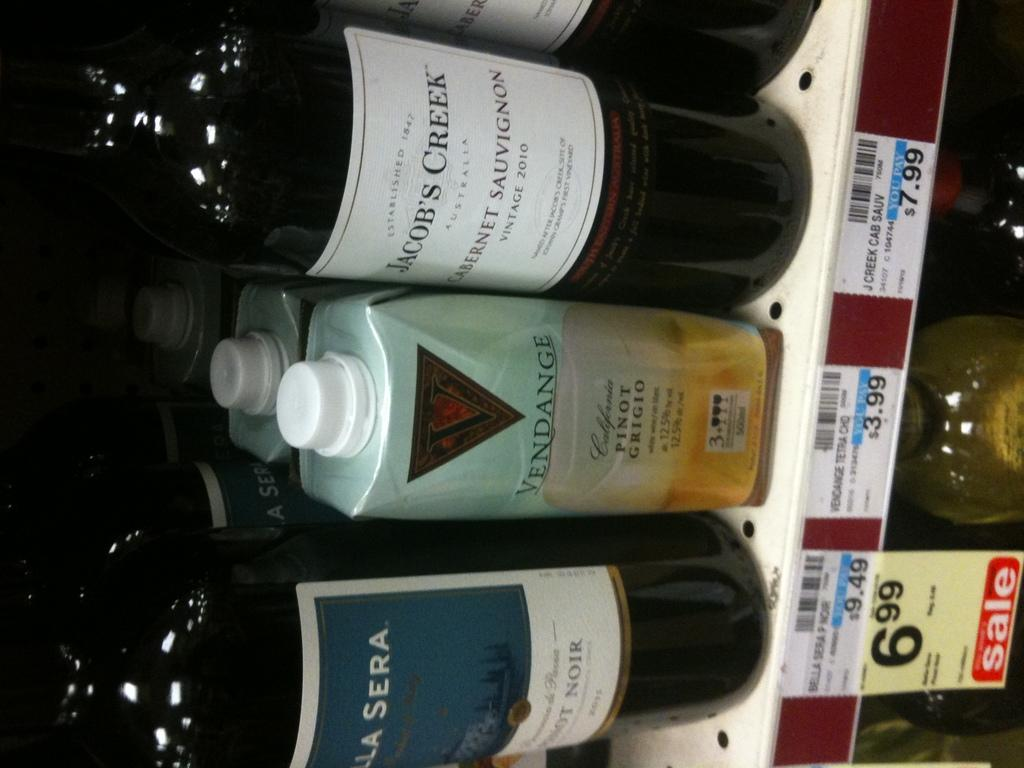<image>
Create a compact narrative representing the image presented. Several bottles, the one on the right being Jacob's Creek. 